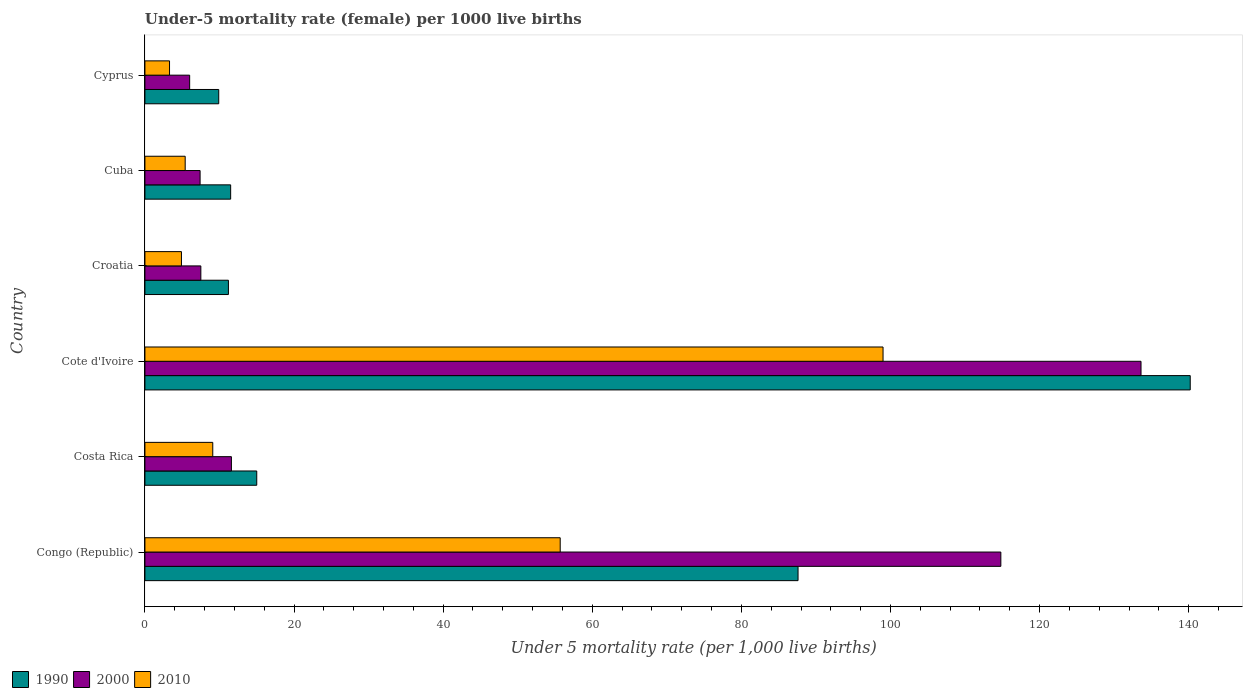Are the number of bars on each tick of the Y-axis equal?
Offer a terse response. Yes. What is the label of the 4th group of bars from the top?
Provide a succinct answer. Cote d'Ivoire. In how many cases, is the number of bars for a given country not equal to the number of legend labels?
Offer a terse response. 0. In which country was the under-five mortality rate in 1990 maximum?
Give a very brief answer. Cote d'Ivoire. In which country was the under-five mortality rate in 2000 minimum?
Offer a very short reply. Cyprus. What is the total under-five mortality rate in 2000 in the graph?
Offer a terse response. 280.9. What is the difference between the under-five mortality rate in 2010 in Cote d'Ivoire and that in Cyprus?
Keep it short and to the point. 95.7. What is the difference between the under-five mortality rate in 1990 in Cuba and the under-five mortality rate in 2010 in Cote d'Ivoire?
Keep it short and to the point. -87.5. What is the average under-five mortality rate in 1990 per country?
Offer a terse response. 45.9. In how many countries, is the under-five mortality rate in 2010 greater than 140 ?
Offer a terse response. 0. What is the ratio of the under-five mortality rate in 1990 in Costa Rica to that in Cuba?
Offer a very short reply. 1.3. Is the under-five mortality rate in 2000 in Costa Rica less than that in Cuba?
Your answer should be compact. No. Is the difference between the under-five mortality rate in 2000 in Congo (Republic) and Cyprus greater than the difference between the under-five mortality rate in 2010 in Congo (Republic) and Cyprus?
Your answer should be compact. Yes. What is the difference between the highest and the second highest under-five mortality rate in 1990?
Ensure brevity in your answer.  52.6. What is the difference between the highest and the lowest under-five mortality rate in 2000?
Make the answer very short. 127.6. What does the 2nd bar from the top in Cuba represents?
Your answer should be very brief. 2000. Is it the case that in every country, the sum of the under-five mortality rate in 2000 and under-five mortality rate in 1990 is greater than the under-five mortality rate in 2010?
Your answer should be compact. Yes. Are all the bars in the graph horizontal?
Provide a succinct answer. Yes. Does the graph contain grids?
Keep it short and to the point. No. What is the title of the graph?
Your answer should be compact. Under-5 mortality rate (female) per 1000 live births. Does "2012" appear as one of the legend labels in the graph?
Your answer should be very brief. No. What is the label or title of the X-axis?
Provide a short and direct response. Under 5 mortality rate (per 1,0 live births). What is the label or title of the Y-axis?
Your answer should be compact. Country. What is the Under 5 mortality rate (per 1,000 live births) in 1990 in Congo (Republic)?
Give a very brief answer. 87.6. What is the Under 5 mortality rate (per 1,000 live births) in 2000 in Congo (Republic)?
Your response must be concise. 114.8. What is the Under 5 mortality rate (per 1,000 live births) in 2010 in Congo (Republic)?
Provide a short and direct response. 55.7. What is the Under 5 mortality rate (per 1,000 live births) of 2000 in Costa Rica?
Offer a very short reply. 11.6. What is the Under 5 mortality rate (per 1,000 live births) of 2010 in Costa Rica?
Offer a terse response. 9.1. What is the Under 5 mortality rate (per 1,000 live births) of 1990 in Cote d'Ivoire?
Your answer should be very brief. 140.2. What is the Under 5 mortality rate (per 1,000 live births) in 2000 in Cote d'Ivoire?
Your answer should be compact. 133.6. What is the Under 5 mortality rate (per 1,000 live births) in 2010 in Cote d'Ivoire?
Give a very brief answer. 99. What is the Under 5 mortality rate (per 1,000 live births) of 1990 in Croatia?
Provide a short and direct response. 11.2. What is the Under 5 mortality rate (per 1,000 live births) in 2010 in Croatia?
Your answer should be very brief. 4.9. What is the Under 5 mortality rate (per 1,000 live births) of 1990 in Cuba?
Your answer should be very brief. 11.5. What is the Under 5 mortality rate (per 1,000 live births) in 1990 in Cyprus?
Offer a terse response. 9.9. Across all countries, what is the maximum Under 5 mortality rate (per 1,000 live births) in 1990?
Offer a terse response. 140.2. Across all countries, what is the maximum Under 5 mortality rate (per 1,000 live births) of 2000?
Your answer should be very brief. 133.6. Across all countries, what is the minimum Under 5 mortality rate (per 1,000 live births) in 2010?
Make the answer very short. 3.3. What is the total Under 5 mortality rate (per 1,000 live births) in 1990 in the graph?
Offer a terse response. 275.4. What is the total Under 5 mortality rate (per 1,000 live births) in 2000 in the graph?
Make the answer very short. 280.9. What is the total Under 5 mortality rate (per 1,000 live births) in 2010 in the graph?
Your answer should be very brief. 177.4. What is the difference between the Under 5 mortality rate (per 1,000 live births) of 1990 in Congo (Republic) and that in Costa Rica?
Your response must be concise. 72.6. What is the difference between the Under 5 mortality rate (per 1,000 live births) in 2000 in Congo (Republic) and that in Costa Rica?
Your response must be concise. 103.2. What is the difference between the Under 5 mortality rate (per 1,000 live births) in 2010 in Congo (Republic) and that in Costa Rica?
Provide a short and direct response. 46.6. What is the difference between the Under 5 mortality rate (per 1,000 live births) of 1990 in Congo (Republic) and that in Cote d'Ivoire?
Your answer should be compact. -52.6. What is the difference between the Under 5 mortality rate (per 1,000 live births) of 2000 in Congo (Republic) and that in Cote d'Ivoire?
Your answer should be compact. -18.8. What is the difference between the Under 5 mortality rate (per 1,000 live births) in 2010 in Congo (Republic) and that in Cote d'Ivoire?
Provide a short and direct response. -43.3. What is the difference between the Under 5 mortality rate (per 1,000 live births) in 1990 in Congo (Republic) and that in Croatia?
Ensure brevity in your answer.  76.4. What is the difference between the Under 5 mortality rate (per 1,000 live births) in 2000 in Congo (Republic) and that in Croatia?
Ensure brevity in your answer.  107.3. What is the difference between the Under 5 mortality rate (per 1,000 live births) of 2010 in Congo (Republic) and that in Croatia?
Keep it short and to the point. 50.8. What is the difference between the Under 5 mortality rate (per 1,000 live births) in 1990 in Congo (Republic) and that in Cuba?
Provide a succinct answer. 76.1. What is the difference between the Under 5 mortality rate (per 1,000 live births) of 2000 in Congo (Republic) and that in Cuba?
Provide a succinct answer. 107.4. What is the difference between the Under 5 mortality rate (per 1,000 live births) in 2010 in Congo (Republic) and that in Cuba?
Offer a very short reply. 50.3. What is the difference between the Under 5 mortality rate (per 1,000 live births) in 1990 in Congo (Republic) and that in Cyprus?
Provide a succinct answer. 77.7. What is the difference between the Under 5 mortality rate (per 1,000 live births) in 2000 in Congo (Republic) and that in Cyprus?
Your response must be concise. 108.8. What is the difference between the Under 5 mortality rate (per 1,000 live births) of 2010 in Congo (Republic) and that in Cyprus?
Your answer should be compact. 52.4. What is the difference between the Under 5 mortality rate (per 1,000 live births) in 1990 in Costa Rica and that in Cote d'Ivoire?
Your answer should be very brief. -125.2. What is the difference between the Under 5 mortality rate (per 1,000 live births) of 2000 in Costa Rica and that in Cote d'Ivoire?
Keep it short and to the point. -122. What is the difference between the Under 5 mortality rate (per 1,000 live births) in 2010 in Costa Rica and that in Cote d'Ivoire?
Give a very brief answer. -89.9. What is the difference between the Under 5 mortality rate (per 1,000 live births) of 1990 in Costa Rica and that in Croatia?
Give a very brief answer. 3.8. What is the difference between the Under 5 mortality rate (per 1,000 live births) in 2000 in Costa Rica and that in Croatia?
Provide a succinct answer. 4.1. What is the difference between the Under 5 mortality rate (per 1,000 live births) of 2010 in Costa Rica and that in Croatia?
Give a very brief answer. 4.2. What is the difference between the Under 5 mortality rate (per 1,000 live births) in 2000 in Costa Rica and that in Cuba?
Offer a terse response. 4.2. What is the difference between the Under 5 mortality rate (per 1,000 live births) in 2010 in Costa Rica and that in Cuba?
Provide a short and direct response. 3.7. What is the difference between the Under 5 mortality rate (per 1,000 live births) of 2010 in Costa Rica and that in Cyprus?
Your response must be concise. 5.8. What is the difference between the Under 5 mortality rate (per 1,000 live births) of 1990 in Cote d'Ivoire and that in Croatia?
Make the answer very short. 129. What is the difference between the Under 5 mortality rate (per 1,000 live births) of 2000 in Cote d'Ivoire and that in Croatia?
Offer a terse response. 126.1. What is the difference between the Under 5 mortality rate (per 1,000 live births) in 2010 in Cote d'Ivoire and that in Croatia?
Keep it short and to the point. 94.1. What is the difference between the Under 5 mortality rate (per 1,000 live births) in 1990 in Cote d'Ivoire and that in Cuba?
Offer a terse response. 128.7. What is the difference between the Under 5 mortality rate (per 1,000 live births) of 2000 in Cote d'Ivoire and that in Cuba?
Your answer should be compact. 126.2. What is the difference between the Under 5 mortality rate (per 1,000 live births) in 2010 in Cote d'Ivoire and that in Cuba?
Give a very brief answer. 93.6. What is the difference between the Under 5 mortality rate (per 1,000 live births) of 1990 in Cote d'Ivoire and that in Cyprus?
Give a very brief answer. 130.3. What is the difference between the Under 5 mortality rate (per 1,000 live births) in 2000 in Cote d'Ivoire and that in Cyprus?
Your answer should be very brief. 127.6. What is the difference between the Under 5 mortality rate (per 1,000 live births) of 2010 in Cote d'Ivoire and that in Cyprus?
Make the answer very short. 95.7. What is the difference between the Under 5 mortality rate (per 1,000 live births) in 2000 in Cuba and that in Cyprus?
Provide a short and direct response. 1.4. What is the difference between the Under 5 mortality rate (per 1,000 live births) in 2010 in Cuba and that in Cyprus?
Ensure brevity in your answer.  2.1. What is the difference between the Under 5 mortality rate (per 1,000 live births) of 1990 in Congo (Republic) and the Under 5 mortality rate (per 1,000 live births) of 2010 in Costa Rica?
Your answer should be compact. 78.5. What is the difference between the Under 5 mortality rate (per 1,000 live births) in 2000 in Congo (Republic) and the Under 5 mortality rate (per 1,000 live births) in 2010 in Costa Rica?
Your answer should be very brief. 105.7. What is the difference between the Under 5 mortality rate (per 1,000 live births) of 1990 in Congo (Republic) and the Under 5 mortality rate (per 1,000 live births) of 2000 in Cote d'Ivoire?
Keep it short and to the point. -46. What is the difference between the Under 5 mortality rate (per 1,000 live births) in 2000 in Congo (Republic) and the Under 5 mortality rate (per 1,000 live births) in 2010 in Cote d'Ivoire?
Offer a terse response. 15.8. What is the difference between the Under 5 mortality rate (per 1,000 live births) of 1990 in Congo (Republic) and the Under 5 mortality rate (per 1,000 live births) of 2000 in Croatia?
Your response must be concise. 80.1. What is the difference between the Under 5 mortality rate (per 1,000 live births) of 1990 in Congo (Republic) and the Under 5 mortality rate (per 1,000 live births) of 2010 in Croatia?
Provide a short and direct response. 82.7. What is the difference between the Under 5 mortality rate (per 1,000 live births) of 2000 in Congo (Republic) and the Under 5 mortality rate (per 1,000 live births) of 2010 in Croatia?
Offer a terse response. 109.9. What is the difference between the Under 5 mortality rate (per 1,000 live births) in 1990 in Congo (Republic) and the Under 5 mortality rate (per 1,000 live births) in 2000 in Cuba?
Your response must be concise. 80.2. What is the difference between the Under 5 mortality rate (per 1,000 live births) in 1990 in Congo (Republic) and the Under 5 mortality rate (per 1,000 live births) in 2010 in Cuba?
Your response must be concise. 82.2. What is the difference between the Under 5 mortality rate (per 1,000 live births) in 2000 in Congo (Republic) and the Under 5 mortality rate (per 1,000 live births) in 2010 in Cuba?
Give a very brief answer. 109.4. What is the difference between the Under 5 mortality rate (per 1,000 live births) of 1990 in Congo (Republic) and the Under 5 mortality rate (per 1,000 live births) of 2000 in Cyprus?
Offer a very short reply. 81.6. What is the difference between the Under 5 mortality rate (per 1,000 live births) in 1990 in Congo (Republic) and the Under 5 mortality rate (per 1,000 live births) in 2010 in Cyprus?
Give a very brief answer. 84.3. What is the difference between the Under 5 mortality rate (per 1,000 live births) in 2000 in Congo (Republic) and the Under 5 mortality rate (per 1,000 live births) in 2010 in Cyprus?
Make the answer very short. 111.5. What is the difference between the Under 5 mortality rate (per 1,000 live births) of 1990 in Costa Rica and the Under 5 mortality rate (per 1,000 live births) of 2000 in Cote d'Ivoire?
Your answer should be very brief. -118.6. What is the difference between the Under 5 mortality rate (per 1,000 live births) in 1990 in Costa Rica and the Under 5 mortality rate (per 1,000 live births) in 2010 in Cote d'Ivoire?
Provide a succinct answer. -84. What is the difference between the Under 5 mortality rate (per 1,000 live births) of 2000 in Costa Rica and the Under 5 mortality rate (per 1,000 live births) of 2010 in Cote d'Ivoire?
Offer a terse response. -87.4. What is the difference between the Under 5 mortality rate (per 1,000 live births) of 1990 in Costa Rica and the Under 5 mortality rate (per 1,000 live births) of 2000 in Croatia?
Keep it short and to the point. 7.5. What is the difference between the Under 5 mortality rate (per 1,000 live births) of 1990 in Costa Rica and the Under 5 mortality rate (per 1,000 live births) of 2010 in Croatia?
Your answer should be very brief. 10.1. What is the difference between the Under 5 mortality rate (per 1,000 live births) in 2000 in Costa Rica and the Under 5 mortality rate (per 1,000 live births) in 2010 in Cuba?
Make the answer very short. 6.2. What is the difference between the Under 5 mortality rate (per 1,000 live births) of 1990 in Costa Rica and the Under 5 mortality rate (per 1,000 live births) of 2010 in Cyprus?
Provide a short and direct response. 11.7. What is the difference between the Under 5 mortality rate (per 1,000 live births) in 1990 in Cote d'Ivoire and the Under 5 mortality rate (per 1,000 live births) in 2000 in Croatia?
Your answer should be very brief. 132.7. What is the difference between the Under 5 mortality rate (per 1,000 live births) in 1990 in Cote d'Ivoire and the Under 5 mortality rate (per 1,000 live births) in 2010 in Croatia?
Make the answer very short. 135.3. What is the difference between the Under 5 mortality rate (per 1,000 live births) of 2000 in Cote d'Ivoire and the Under 5 mortality rate (per 1,000 live births) of 2010 in Croatia?
Your answer should be compact. 128.7. What is the difference between the Under 5 mortality rate (per 1,000 live births) in 1990 in Cote d'Ivoire and the Under 5 mortality rate (per 1,000 live births) in 2000 in Cuba?
Your answer should be compact. 132.8. What is the difference between the Under 5 mortality rate (per 1,000 live births) of 1990 in Cote d'Ivoire and the Under 5 mortality rate (per 1,000 live births) of 2010 in Cuba?
Provide a short and direct response. 134.8. What is the difference between the Under 5 mortality rate (per 1,000 live births) of 2000 in Cote d'Ivoire and the Under 5 mortality rate (per 1,000 live births) of 2010 in Cuba?
Provide a short and direct response. 128.2. What is the difference between the Under 5 mortality rate (per 1,000 live births) of 1990 in Cote d'Ivoire and the Under 5 mortality rate (per 1,000 live births) of 2000 in Cyprus?
Make the answer very short. 134.2. What is the difference between the Under 5 mortality rate (per 1,000 live births) of 1990 in Cote d'Ivoire and the Under 5 mortality rate (per 1,000 live births) of 2010 in Cyprus?
Make the answer very short. 136.9. What is the difference between the Under 5 mortality rate (per 1,000 live births) of 2000 in Cote d'Ivoire and the Under 5 mortality rate (per 1,000 live births) of 2010 in Cyprus?
Your answer should be compact. 130.3. What is the difference between the Under 5 mortality rate (per 1,000 live births) in 1990 in Croatia and the Under 5 mortality rate (per 1,000 live births) in 2000 in Cuba?
Provide a short and direct response. 3.8. What is the difference between the Under 5 mortality rate (per 1,000 live births) in 2000 in Croatia and the Under 5 mortality rate (per 1,000 live births) in 2010 in Cuba?
Your answer should be compact. 2.1. What is the difference between the Under 5 mortality rate (per 1,000 live births) of 2000 in Croatia and the Under 5 mortality rate (per 1,000 live births) of 2010 in Cyprus?
Your answer should be very brief. 4.2. What is the difference between the Under 5 mortality rate (per 1,000 live births) of 2000 in Cuba and the Under 5 mortality rate (per 1,000 live births) of 2010 in Cyprus?
Your answer should be compact. 4.1. What is the average Under 5 mortality rate (per 1,000 live births) of 1990 per country?
Provide a succinct answer. 45.9. What is the average Under 5 mortality rate (per 1,000 live births) in 2000 per country?
Your answer should be very brief. 46.82. What is the average Under 5 mortality rate (per 1,000 live births) in 2010 per country?
Your answer should be compact. 29.57. What is the difference between the Under 5 mortality rate (per 1,000 live births) in 1990 and Under 5 mortality rate (per 1,000 live births) in 2000 in Congo (Republic)?
Offer a terse response. -27.2. What is the difference between the Under 5 mortality rate (per 1,000 live births) in 1990 and Under 5 mortality rate (per 1,000 live births) in 2010 in Congo (Republic)?
Your response must be concise. 31.9. What is the difference between the Under 5 mortality rate (per 1,000 live births) in 2000 and Under 5 mortality rate (per 1,000 live births) in 2010 in Congo (Republic)?
Make the answer very short. 59.1. What is the difference between the Under 5 mortality rate (per 1,000 live births) in 2000 and Under 5 mortality rate (per 1,000 live births) in 2010 in Costa Rica?
Offer a very short reply. 2.5. What is the difference between the Under 5 mortality rate (per 1,000 live births) in 1990 and Under 5 mortality rate (per 1,000 live births) in 2000 in Cote d'Ivoire?
Provide a short and direct response. 6.6. What is the difference between the Under 5 mortality rate (per 1,000 live births) of 1990 and Under 5 mortality rate (per 1,000 live births) of 2010 in Cote d'Ivoire?
Ensure brevity in your answer.  41.2. What is the difference between the Under 5 mortality rate (per 1,000 live births) in 2000 and Under 5 mortality rate (per 1,000 live births) in 2010 in Cote d'Ivoire?
Provide a succinct answer. 34.6. What is the difference between the Under 5 mortality rate (per 1,000 live births) of 1990 and Under 5 mortality rate (per 1,000 live births) of 2000 in Croatia?
Provide a short and direct response. 3.7. What is the difference between the Under 5 mortality rate (per 1,000 live births) in 2000 and Under 5 mortality rate (per 1,000 live births) in 2010 in Cuba?
Make the answer very short. 2. What is the difference between the Under 5 mortality rate (per 1,000 live births) of 1990 and Under 5 mortality rate (per 1,000 live births) of 2000 in Cyprus?
Your response must be concise. 3.9. What is the difference between the Under 5 mortality rate (per 1,000 live births) of 2000 and Under 5 mortality rate (per 1,000 live births) of 2010 in Cyprus?
Provide a succinct answer. 2.7. What is the ratio of the Under 5 mortality rate (per 1,000 live births) in 1990 in Congo (Republic) to that in Costa Rica?
Provide a succinct answer. 5.84. What is the ratio of the Under 5 mortality rate (per 1,000 live births) of 2000 in Congo (Republic) to that in Costa Rica?
Your answer should be very brief. 9.9. What is the ratio of the Under 5 mortality rate (per 1,000 live births) of 2010 in Congo (Republic) to that in Costa Rica?
Provide a short and direct response. 6.12. What is the ratio of the Under 5 mortality rate (per 1,000 live births) of 1990 in Congo (Republic) to that in Cote d'Ivoire?
Give a very brief answer. 0.62. What is the ratio of the Under 5 mortality rate (per 1,000 live births) in 2000 in Congo (Republic) to that in Cote d'Ivoire?
Your response must be concise. 0.86. What is the ratio of the Under 5 mortality rate (per 1,000 live births) in 2010 in Congo (Republic) to that in Cote d'Ivoire?
Ensure brevity in your answer.  0.56. What is the ratio of the Under 5 mortality rate (per 1,000 live births) of 1990 in Congo (Republic) to that in Croatia?
Your response must be concise. 7.82. What is the ratio of the Under 5 mortality rate (per 1,000 live births) of 2000 in Congo (Republic) to that in Croatia?
Your response must be concise. 15.31. What is the ratio of the Under 5 mortality rate (per 1,000 live births) in 2010 in Congo (Republic) to that in Croatia?
Provide a succinct answer. 11.37. What is the ratio of the Under 5 mortality rate (per 1,000 live births) in 1990 in Congo (Republic) to that in Cuba?
Ensure brevity in your answer.  7.62. What is the ratio of the Under 5 mortality rate (per 1,000 live births) in 2000 in Congo (Republic) to that in Cuba?
Your answer should be compact. 15.51. What is the ratio of the Under 5 mortality rate (per 1,000 live births) in 2010 in Congo (Republic) to that in Cuba?
Your answer should be compact. 10.31. What is the ratio of the Under 5 mortality rate (per 1,000 live births) of 1990 in Congo (Republic) to that in Cyprus?
Ensure brevity in your answer.  8.85. What is the ratio of the Under 5 mortality rate (per 1,000 live births) in 2000 in Congo (Republic) to that in Cyprus?
Give a very brief answer. 19.13. What is the ratio of the Under 5 mortality rate (per 1,000 live births) in 2010 in Congo (Republic) to that in Cyprus?
Provide a short and direct response. 16.88. What is the ratio of the Under 5 mortality rate (per 1,000 live births) of 1990 in Costa Rica to that in Cote d'Ivoire?
Your answer should be compact. 0.11. What is the ratio of the Under 5 mortality rate (per 1,000 live births) of 2000 in Costa Rica to that in Cote d'Ivoire?
Offer a terse response. 0.09. What is the ratio of the Under 5 mortality rate (per 1,000 live births) in 2010 in Costa Rica to that in Cote d'Ivoire?
Give a very brief answer. 0.09. What is the ratio of the Under 5 mortality rate (per 1,000 live births) in 1990 in Costa Rica to that in Croatia?
Ensure brevity in your answer.  1.34. What is the ratio of the Under 5 mortality rate (per 1,000 live births) in 2000 in Costa Rica to that in Croatia?
Provide a short and direct response. 1.55. What is the ratio of the Under 5 mortality rate (per 1,000 live births) of 2010 in Costa Rica to that in Croatia?
Give a very brief answer. 1.86. What is the ratio of the Under 5 mortality rate (per 1,000 live births) in 1990 in Costa Rica to that in Cuba?
Your answer should be very brief. 1.3. What is the ratio of the Under 5 mortality rate (per 1,000 live births) of 2000 in Costa Rica to that in Cuba?
Your answer should be very brief. 1.57. What is the ratio of the Under 5 mortality rate (per 1,000 live births) of 2010 in Costa Rica to that in Cuba?
Provide a short and direct response. 1.69. What is the ratio of the Under 5 mortality rate (per 1,000 live births) of 1990 in Costa Rica to that in Cyprus?
Ensure brevity in your answer.  1.52. What is the ratio of the Under 5 mortality rate (per 1,000 live births) in 2000 in Costa Rica to that in Cyprus?
Your answer should be compact. 1.93. What is the ratio of the Under 5 mortality rate (per 1,000 live births) of 2010 in Costa Rica to that in Cyprus?
Your answer should be very brief. 2.76. What is the ratio of the Under 5 mortality rate (per 1,000 live births) in 1990 in Cote d'Ivoire to that in Croatia?
Make the answer very short. 12.52. What is the ratio of the Under 5 mortality rate (per 1,000 live births) in 2000 in Cote d'Ivoire to that in Croatia?
Give a very brief answer. 17.81. What is the ratio of the Under 5 mortality rate (per 1,000 live births) of 2010 in Cote d'Ivoire to that in Croatia?
Provide a short and direct response. 20.2. What is the ratio of the Under 5 mortality rate (per 1,000 live births) in 1990 in Cote d'Ivoire to that in Cuba?
Your response must be concise. 12.19. What is the ratio of the Under 5 mortality rate (per 1,000 live births) in 2000 in Cote d'Ivoire to that in Cuba?
Keep it short and to the point. 18.05. What is the ratio of the Under 5 mortality rate (per 1,000 live births) in 2010 in Cote d'Ivoire to that in Cuba?
Give a very brief answer. 18.33. What is the ratio of the Under 5 mortality rate (per 1,000 live births) of 1990 in Cote d'Ivoire to that in Cyprus?
Your answer should be compact. 14.16. What is the ratio of the Under 5 mortality rate (per 1,000 live births) in 2000 in Cote d'Ivoire to that in Cyprus?
Provide a succinct answer. 22.27. What is the ratio of the Under 5 mortality rate (per 1,000 live births) in 1990 in Croatia to that in Cuba?
Keep it short and to the point. 0.97. What is the ratio of the Under 5 mortality rate (per 1,000 live births) of 2000 in Croatia to that in Cuba?
Provide a succinct answer. 1.01. What is the ratio of the Under 5 mortality rate (per 1,000 live births) of 2010 in Croatia to that in Cuba?
Give a very brief answer. 0.91. What is the ratio of the Under 5 mortality rate (per 1,000 live births) in 1990 in Croatia to that in Cyprus?
Keep it short and to the point. 1.13. What is the ratio of the Under 5 mortality rate (per 1,000 live births) of 2010 in Croatia to that in Cyprus?
Your response must be concise. 1.48. What is the ratio of the Under 5 mortality rate (per 1,000 live births) in 1990 in Cuba to that in Cyprus?
Make the answer very short. 1.16. What is the ratio of the Under 5 mortality rate (per 1,000 live births) of 2000 in Cuba to that in Cyprus?
Offer a very short reply. 1.23. What is the ratio of the Under 5 mortality rate (per 1,000 live births) of 2010 in Cuba to that in Cyprus?
Provide a short and direct response. 1.64. What is the difference between the highest and the second highest Under 5 mortality rate (per 1,000 live births) in 1990?
Provide a short and direct response. 52.6. What is the difference between the highest and the second highest Under 5 mortality rate (per 1,000 live births) in 2010?
Give a very brief answer. 43.3. What is the difference between the highest and the lowest Under 5 mortality rate (per 1,000 live births) of 1990?
Make the answer very short. 130.3. What is the difference between the highest and the lowest Under 5 mortality rate (per 1,000 live births) of 2000?
Provide a short and direct response. 127.6. What is the difference between the highest and the lowest Under 5 mortality rate (per 1,000 live births) of 2010?
Offer a terse response. 95.7. 